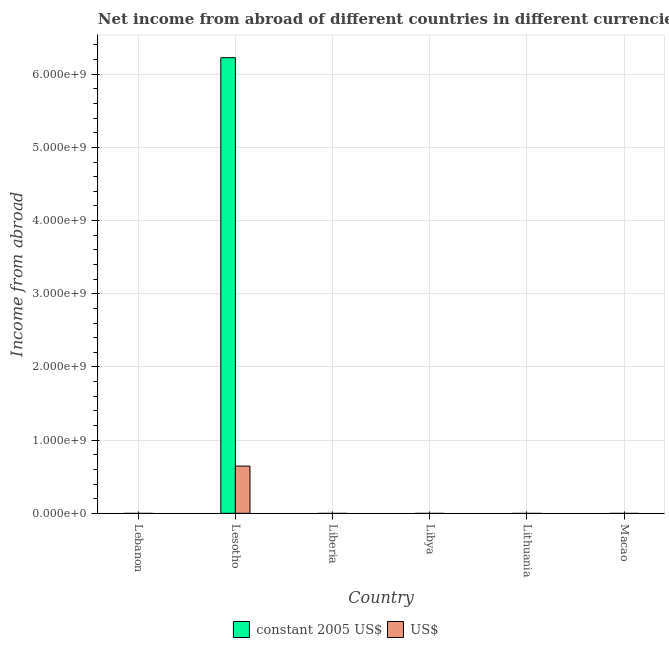How many different coloured bars are there?
Make the answer very short. 2. Are the number of bars on each tick of the X-axis equal?
Your response must be concise. No. How many bars are there on the 4th tick from the left?
Offer a terse response. 0. What is the label of the 1st group of bars from the left?
Offer a very short reply. Lebanon. In how many cases, is the number of bars for a given country not equal to the number of legend labels?
Offer a terse response. 5. What is the income from abroad in us$ in Lebanon?
Keep it short and to the point. 0. Across all countries, what is the maximum income from abroad in constant 2005 us$?
Offer a very short reply. 6.23e+09. Across all countries, what is the minimum income from abroad in us$?
Give a very brief answer. 0. In which country was the income from abroad in us$ maximum?
Ensure brevity in your answer.  Lesotho. What is the total income from abroad in us$ in the graph?
Make the answer very short. 6.45e+08. What is the difference between the income from abroad in constant 2005 us$ in Lesotho and the income from abroad in us$ in Lebanon?
Your answer should be compact. 6.23e+09. What is the average income from abroad in constant 2005 us$ per country?
Provide a succinct answer. 1.04e+09. What is the difference between the income from abroad in constant 2005 us$ and income from abroad in us$ in Lesotho?
Your response must be concise. 5.58e+09. What is the difference between the highest and the lowest income from abroad in constant 2005 us$?
Your answer should be very brief. 6.23e+09. In how many countries, is the income from abroad in constant 2005 us$ greater than the average income from abroad in constant 2005 us$ taken over all countries?
Your answer should be compact. 1. How many bars are there?
Provide a succinct answer. 2. What is the difference between two consecutive major ticks on the Y-axis?
Offer a very short reply. 1.00e+09. How many legend labels are there?
Your answer should be compact. 2. How are the legend labels stacked?
Give a very brief answer. Horizontal. What is the title of the graph?
Your response must be concise. Net income from abroad of different countries in different currencies. Does "Non-pregnant women" appear as one of the legend labels in the graph?
Offer a terse response. No. What is the label or title of the Y-axis?
Your answer should be very brief. Income from abroad. What is the Income from abroad of constant 2005 US$ in Lebanon?
Ensure brevity in your answer.  0. What is the Income from abroad in US$ in Lebanon?
Provide a succinct answer. 0. What is the Income from abroad of constant 2005 US$ in Lesotho?
Give a very brief answer. 6.23e+09. What is the Income from abroad of US$ in Lesotho?
Keep it short and to the point. 6.45e+08. What is the Income from abroad in US$ in Liberia?
Your response must be concise. 0. What is the Income from abroad of US$ in Libya?
Provide a succinct answer. 0. What is the Income from abroad of constant 2005 US$ in Lithuania?
Offer a very short reply. 0. What is the Income from abroad of US$ in Lithuania?
Offer a very short reply. 0. What is the Income from abroad of US$ in Macao?
Your answer should be very brief. 0. Across all countries, what is the maximum Income from abroad in constant 2005 US$?
Provide a short and direct response. 6.23e+09. Across all countries, what is the maximum Income from abroad in US$?
Provide a succinct answer. 6.45e+08. Across all countries, what is the minimum Income from abroad in constant 2005 US$?
Offer a very short reply. 0. Across all countries, what is the minimum Income from abroad in US$?
Provide a short and direct response. 0. What is the total Income from abroad of constant 2005 US$ in the graph?
Make the answer very short. 6.23e+09. What is the total Income from abroad in US$ in the graph?
Offer a terse response. 6.45e+08. What is the average Income from abroad in constant 2005 US$ per country?
Your response must be concise. 1.04e+09. What is the average Income from abroad in US$ per country?
Make the answer very short. 1.07e+08. What is the difference between the Income from abroad in constant 2005 US$ and Income from abroad in US$ in Lesotho?
Provide a short and direct response. 5.58e+09. What is the difference between the highest and the lowest Income from abroad in constant 2005 US$?
Provide a short and direct response. 6.23e+09. What is the difference between the highest and the lowest Income from abroad of US$?
Offer a very short reply. 6.45e+08. 